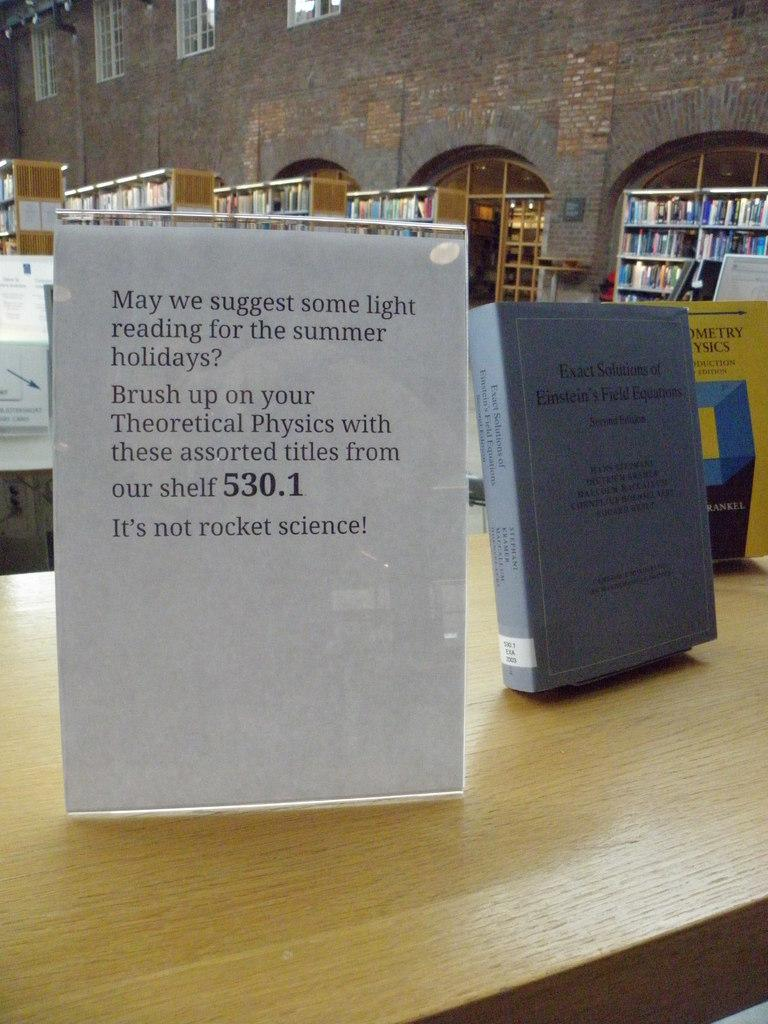<image>
Present a compact description of the photo's key features. a sign inside a library says May we Suggest some light reading 